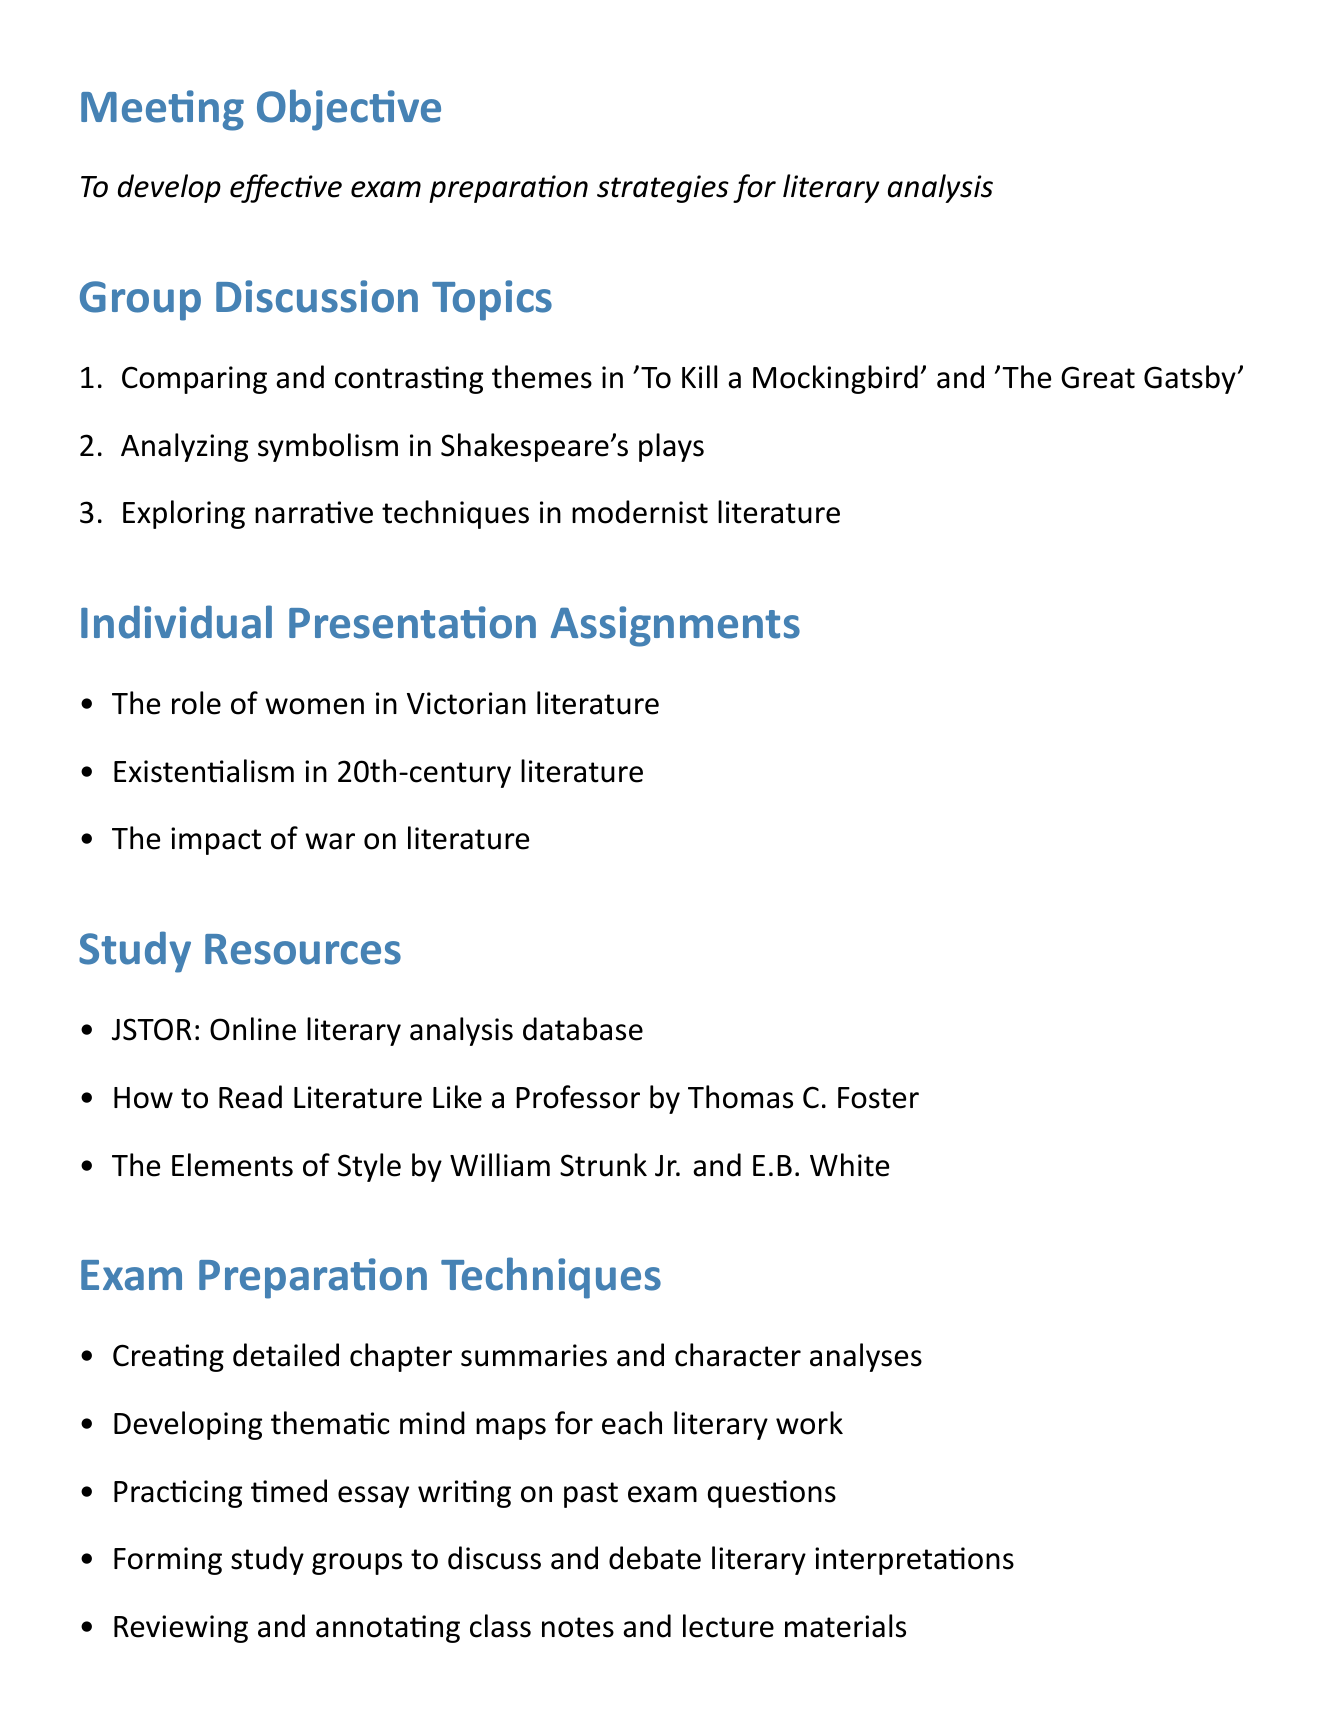What is the meeting objective? The meeting objective is stated clearly in the document as the purpose of the gathering.
Answer: To develop effective exam preparation strategies for literary analysis What are the first individual presentation themes listed? The document outlines the individual presentation assignments, starting with the first theme.
Answer: The role of women in Victorian literature What is one of the key points for the group discussion on Shakespeare's plays? The key points for each group discussion topic provide insight on what to focus on during conversations.
Answer: Blood imagery in 'Macbeth' What is the date of the final literature exam? The important dates section lists significant upcoming events along with their respective dates.
Answer: May 10, 2023 Which resource is recommended for understanding literary themes and symbols? The study resources section includes various tools and guides to assist students in their preparation.
Answer: How to Read Literature Like a Professor by Thomas C. Foster How many topics are listed under group discussion topics? The group discussion topics section enumerates several areas for collective discussion in the meeting.
Answer: Three What technique involves creating detailed chapter summaries? The exam preparation techniques describe methods for reviewing and studying literary works effectively.
Answer: Creating detailed chapter summaries and character analyses What is the date for the individual presentations due? The important dates provide clear deadlines for various tasks in relation to the meeting.
Answer: April 29, 2023 